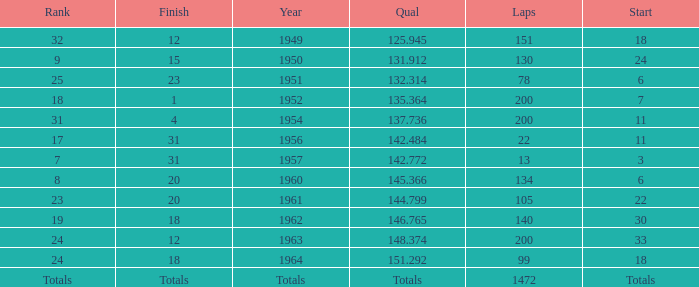What kind of finish involves completing over 200 laps? Totals. 